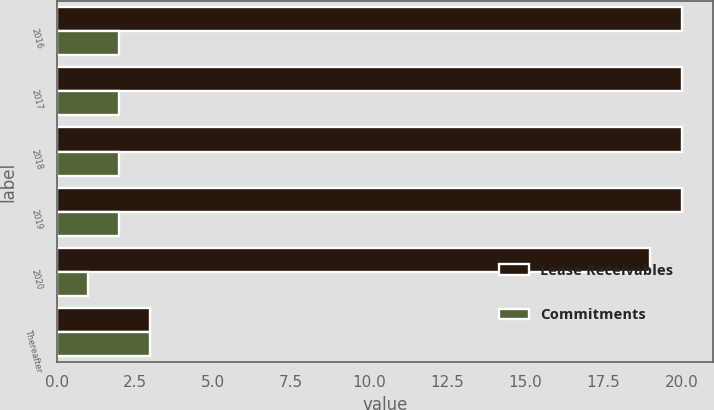<chart> <loc_0><loc_0><loc_500><loc_500><stacked_bar_chart><ecel><fcel>2016<fcel>2017<fcel>2018<fcel>2019<fcel>2020<fcel>Thereafter<nl><fcel>Lease Receivables<fcel>20<fcel>20<fcel>20<fcel>20<fcel>19<fcel>3<nl><fcel>Commitments<fcel>2<fcel>2<fcel>2<fcel>2<fcel>1<fcel>3<nl></chart> 